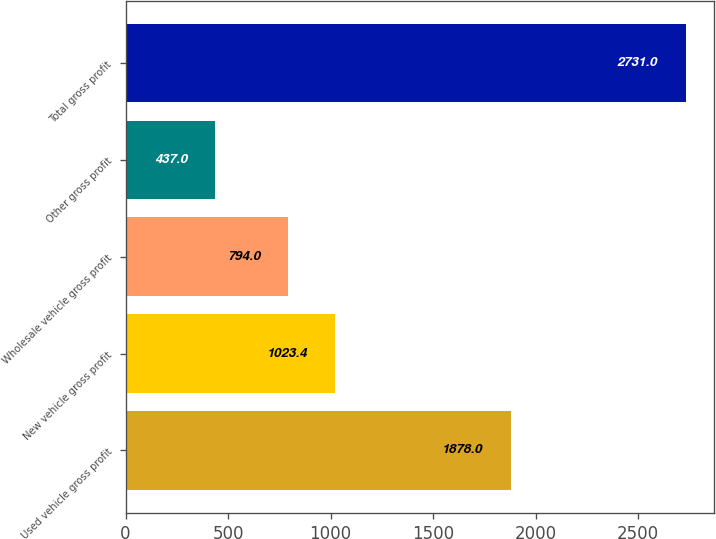Convert chart to OTSL. <chart><loc_0><loc_0><loc_500><loc_500><bar_chart><fcel>Used vehicle gross profit<fcel>New vehicle gross profit<fcel>Wholesale vehicle gross profit<fcel>Other gross profit<fcel>Total gross profit<nl><fcel>1878<fcel>1023.4<fcel>794<fcel>437<fcel>2731<nl></chart> 